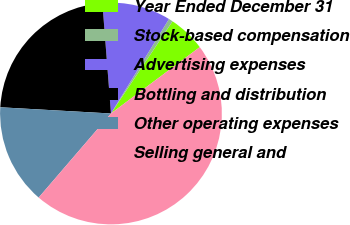Convert chart to OTSL. <chart><loc_0><loc_0><loc_500><loc_500><pie_chart><fcel>Year Ended December 31<fcel>Stock-based compensation<fcel>Advertising expenses<fcel>Bottling and distribution<fcel>Other operating expenses<fcel>Selling general and<nl><fcel>5.41%<fcel>0.61%<fcel>10.0%<fcel>22.87%<fcel>14.59%<fcel>46.52%<nl></chart> 